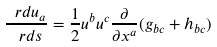Convert formula to latex. <formula><loc_0><loc_0><loc_500><loc_500>\frac { \ r d u _ { a } } { \ r d s } = \frac { 1 } { 2 } u ^ { b } u ^ { c } \frac { \partial } { \partial x ^ { a } } ( g _ { b c } + h _ { b c } )</formula> 